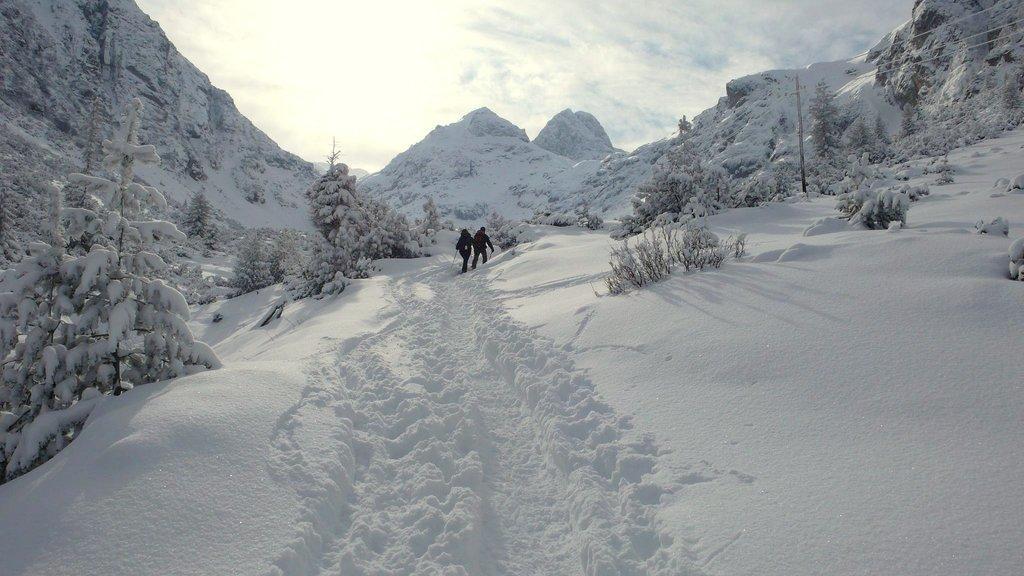How many people are in the image? There are two people in the image. What is the weather like in the image? There is snow visible in the image, indicating a cold and likely wintery environment. What type of natural features can be seen in the image? There are trees and mountains visible in the image. What is the background of the image? The background of the image includes a pole with wires and the sky. What type of shoe can be seen on the mountain in the image? There is no shoe visible on the mountain in the image. What kind of ball is being played with by the people in the image? There is no ball present in the image; the two people are not engaged in any activity involving a ball. 